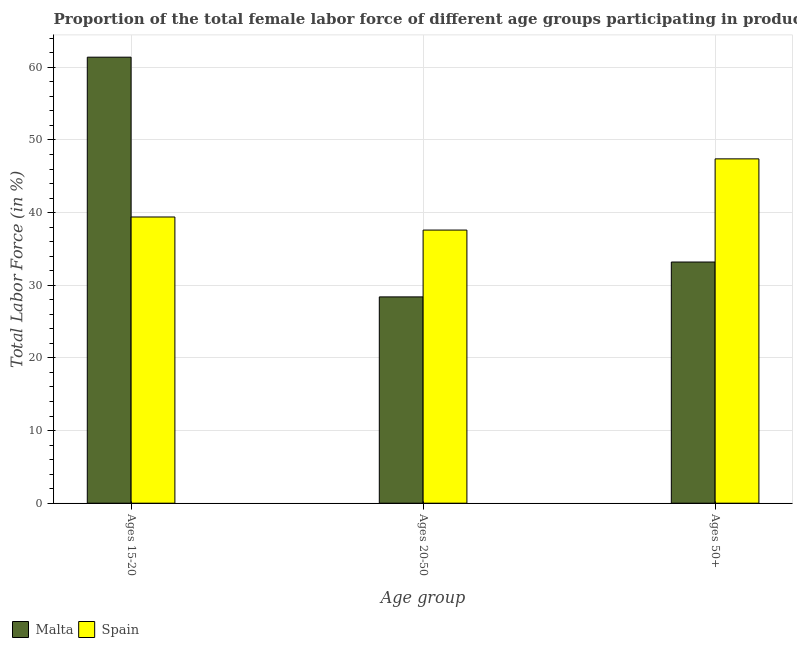How many different coloured bars are there?
Offer a terse response. 2. How many groups of bars are there?
Ensure brevity in your answer.  3. How many bars are there on the 3rd tick from the right?
Provide a short and direct response. 2. What is the label of the 1st group of bars from the left?
Offer a very short reply. Ages 15-20. What is the percentage of female labor force within the age group 20-50 in Spain?
Keep it short and to the point. 37.6. Across all countries, what is the maximum percentage of female labor force above age 50?
Give a very brief answer. 47.4. Across all countries, what is the minimum percentage of female labor force above age 50?
Make the answer very short. 33.2. In which country was the percentage of female labor force within the age group 15-20 maximum?
Provide a succinct answer. Malta. In which country was the percentage of female labor force within the age group 15-20 minimum?
Your response must be concise. Spain. What is the total percentage of female labor force within the age group 20-50 in the graph?
Offer a very short reply. 66. What is the difference between the percentage of female labor force above age 50 in Spain and that in Malta?
Make the answer very short. 14.2. What is the difference between the percentage of female labor force within the age group 15-20 in Spain and the percentage of female labor force above age 50 in Malta?
Provide a short and direct response. 6.2. What is the average percentage of female labor force within the age group 20-50 per country?
Give a very brief answer. 33. What is the difference between the percentage of female labor force within the age group 20-50 and percentage of female labor force above age 50 in Malta?
Make the answer very short. -4.8. In how many countries, is the percentage of female labor force within the age group 15-20 greater than 28 %?
Offer a very short reply. 2. What is the ratio of the percentage of female labor force above age 50 in Malta to that in Spain?
Provide a short and direct response. 0.7. Is the difference between the percentage of female labor force within the age group 15-20 in Malta and Spain greater than the difference between the percentage of female labor force within the age group 20-50 in Malta and Spain?
Offer a very short reply. Yes. What is the difference between the highest and the lowest percentage of female labor force above age 50?
Offer a terse response. 14.2. In how many countries, is the percentage of female labor force within the age group 20-50 greater than the average percentage of female labor force within the age group 20-50 taken over all countries?
Your answer should be very brief. 1. Is the sum of the percentage of female labor force within the age group 15-20 in Malta and Spain greater than the maximum percentage of female labor force within the age group 20-50 across all countries?
Give a very brief answer. Yes. What does the 1st bar from the left in Ages 50+ represents?
Provide a short and direct response. Malta. What does the 2nd bar from the right in Ages 15-20 represents?
Give a very brief answer. Malta. Is it the case that in every country, the sum of the percentage of female labor force within the age group 15-20 and percentage of female labor force within the age group 20-50 is greater than the percentage of female labor force above age 50?
Provide a short and direct response. Yes. How many bars are there?
Your answer should be very brief. 6. Are all the bars in the graph horizontal?
Ensure brevity in your answer.  No. Where does the legend appear in the graph?
Ensure brevity in your answer.  Bottom left. How are the legend labels stacked?
Your response must be concise. Horizontal. What is the title of the graph?
Give a very brief answer. Proportion of the total female labor force of different age groups participating in production in 1996. Does "Thailand" appear as one of the legend labels in the graph?
Your answer should be compact. No. What is the label or title of the X-axis?
Offer a terse response. Age group. What is the Total Labor Force (in %) of Malta in Ages 15-20?
Your response must be concise. 61.4. What is the Total Labor Force (in %) of Spain in Ages 15-20?
Your answer should be compact. 39.4. What is the Total Labor Force (in %) in Malta in Ages 20-50?
Give a very brief answer. 28.4. What is the Total Labor Force (in %) in Spain in Ages 20-50?
Your response must be concise. 37.6. What is the Total Labor Force (in %) in Malta in Ages 50+?
Your answer should be compact. 33.2. What is the Total Labor Force (in %) of Spain in Ages 50+?
Provide a short and direct response. 47.4. Across all Age group, what is the maximum Total Labor Force (in %) in Malta?
Keep it short and to the point. 61.4. Across all Age group, what is the maximum Total Labor Force (in %) in Spain?
Your response must be concise. 47.4. Across all Age group, what is the minimum Total Labor Force (in %) in Malta?
Provide a short and direct response. 28.4. Across all Age group, what is the minimum Total Labor Force (in %) in Spain?
Offer a terse response. 37.6. What is the total Total Labor Force (in %) in Malta in the graph?
Offer a very short reply. 123. What is the total Total Labor Force (in %) of Spain in the graph?
Ensure brevity in your answer.  124.4. What is the difference between the Total Labor Force (in %) of Spain in Ages 15-20 and that in Ages 20-50?
Offer a terse response. 1.8. What is the difference between the Total Labor Force (in %) of Malta in Ages 15-20 and that in Ages 50+?
Your answer should be compact. 28.2. What is the difference between the Total Labor Force (in %) of Spain in Ages 15-20 and that in Ages 50+?
Offer a very short reply. -8. What is the difference between the Total Labor Force (in %) in Malta in Ages 20-50 and that in Ages 50+?
Provide a short and direct response. -4.8. What is the difference between the Total Labor Force (in %) of Spain in Ages 20-50 and that in Ages 50+?
Make the answer very short. -9.8. What is the difference between the Total Labor Force (in %) in Malta in Ages 15-20 and the Total Labor Force (in %) in Spain in Ages 20-50?
Keep it short and to the point. 23.8. What is the average Total Labor Force (in %) of Malta per Age group?
Your response must be concise. 41. What is the average Total Labor Force (in %) in Spain per Age group?
Ensure brevity in your answer.  41.47. What is the difference between the Total Labor Force (in %) in Malta and Total Labor Force (in %) in Spain in Ages 15-20?
Provide a succinct answer. 22. What is the ratio of the Total Labor Force (in %) in Malta in Ages 15-20 to that in Ages 20-50?
Offer a terse response. 2.16. What is the ratio of the Total Labor Force (in %) in Spain in Ages 15-20 to that in Ages 20-50?
Make the answer very short. 1.05. What is the ratio of the Total Labor Force (in %) in Malta in Ages 15-20 to that in Ages 50+?
Your response must be concise. 1.85. What is the ratio of the Total Labor Force (in %) in Spain in Ages 15-20 to that in Ages 50+?
Ensure brevity in your answer.  0.83. What is the ratio of the Total Labor Force (in %) of Malta in Ages 20-50 to that in Ages 50+?
Ensure brevity in your answer.  0.86. What is the ratio of the Total Labor Force (in %) of Spain in Ages 20-50 to that in Ages 50+?
Your response must be concise. 0.79. What is the difference between the highest and the second highest Total Labor Force (in %) of Malta?
Give a very brief answer. 28.2. What is the difference between the highest and the second highest Total Labor Force (in %) in Spain?
Your answer should be very brief. 8. 